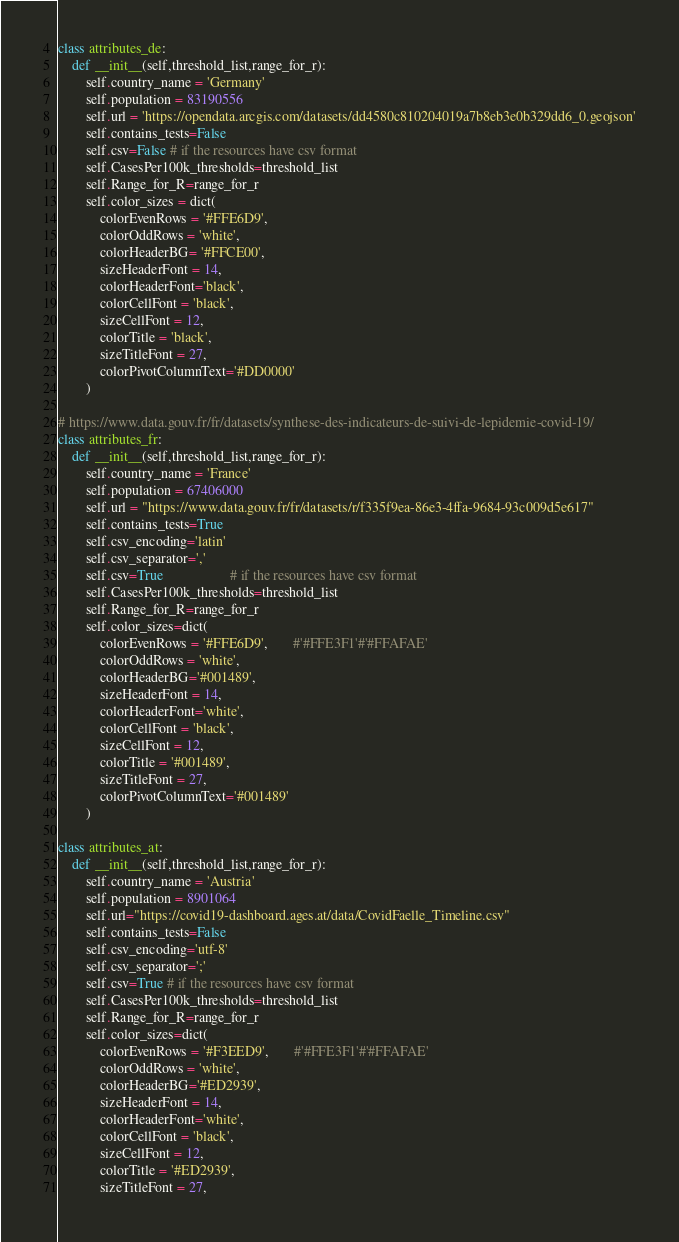<code> <loc_0><loc_0><loc_500><loc_500><_Python_>class attributes_de:
    def __init__(self,threshold_list,range_for_r):
        self.country_name = 'Germany'
        self.population = 83190556
        self.url = 'https://opendata.arcgis.com/datasets/dd4580c810204019a7b8eb3e0b329dd6_0.geojson'
        self.contains_tests=False
        self.csv=False # if the resources have csv format
        self.CasesPer100k_thresholds=threshold_list
        self.Range_for_R=range_for_r
        self.color_sizes = dict(
            colorEvenRows = '#FFE6D9',
            colorOddRows = 'white',
            colorHeaderBG= '#FFCE00',
            sizeHeaderFont = 14,
            colorHeaderFont='black',
            colorCellFont = 'black',
            sizeCellFont = 12,
            colorTitle = 'black',
            sizeTitleFont = 27,
            colorPivotColumnText='#DD0000'
        )

# https://www.data.gouv.fr/fr/datasets/synthese-des-indicateurs-de-suivi-de-lepidemie-covid-19/
class attributes_fr:
    def __init__(self,threshold_list,range_for_r):
        self.country_name = 'France'
        self.population = 67406000
        self.url = "https://www.data.gouv.fr/fr/datasets/r/f335f9ea-86e3-4ffa-9684-93c009d5e617"
        self.contains_tests=True
        self.csv_encoding='latin'
        self.csv_separator=','
        self.csv=True                   # if the resources have csv format
        self.CasesPer100k_thresholds=threshold_list
        self.Range_for_R=range_for_r
        self.color_sizes=dict(
            colorEvenRows = '#FFE6D9',       #'#FFE3F1'#'#FFAFAE'
            colorOddRows = 'white',
            colorHeaderBG='#001489',
            sizeHeaderFont = 14,
            colorHeaderFont='white',
            colorCellFont = 'black',
            sizeCellFont = 12,
            colorTitle = '#001489',
            sizeTitleFont = 27,
            colorPivotColumnText='#001489'
        )

class attributes_at:
    def __init__(self,threshold_list,range_for_r):
        self.country_name = 'Austria'
        self.population = 8901064
        self.url="https://covid19-dashboard.ages.at/data/CovidFaelle_Timeline.csv"
        self.contains_tests=False
        self.csv_encoding='utf-8'
        self.csv_separator=';'
        self.csv=True # if the resources have csv format
        self.CasesPer100k_thresholds=threshold_list
        self.Range_for_R=range_for_r
        self.color_sizes=dict(
            colorEvenRows = '#F3EED9',       #'#FFE3F1'#'#FFAFAE'
            colorOddRows = 'white',
            colorHeaderBG='#ED2939',
            sizeHeaderFont = 14,
            colorHeaderFont='white',
            colorCellFont = 'black',
            sizeCellFont = 12,
            colorTitle = '#ED2939',
            sizeTitleFont = 27,</code> 